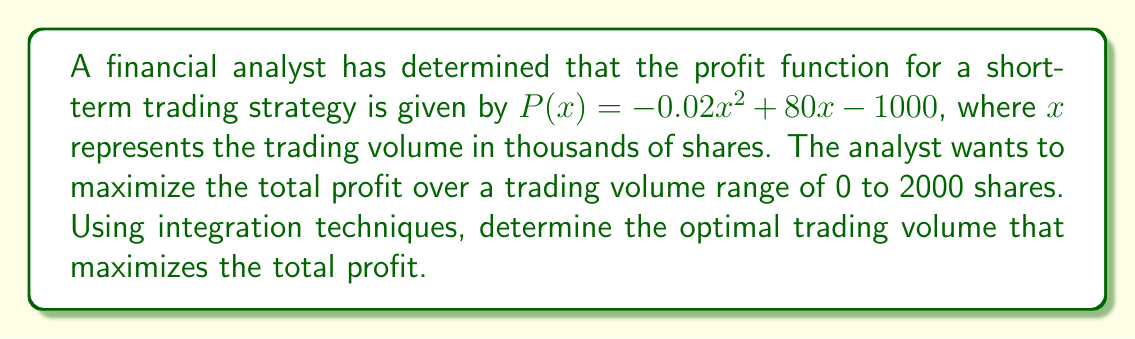Can you solve this math problem? To solve this problem, we'll follow these steps:

1) First, we need to find the total profit function by integrating $P(x)$ over the given range:

   $$\text{Total Profit} = \int_0^2 P(x) dx$$

2) Integrate $P(x)$ with respect to $x$:

   $$\int_0^2 (-0.02x^2 + 80x - 1000) dx$$
   
   $$= [-\frac{0.02}{3}x^3 + 40x^2 - 1000x]_0^2$$

3) Evaluate the integral at the bounds:

   $$= [-\frac{0.02}{3}(2^3) + 40(2^2) - 1000(2)] - [-\frac{0.02}{3}(0^3) + 40(0^2) - 1000(0)]$$
   
   $$= [-0.16 + 160 - 2000] - [0]$$
   
   $$= -1840.16$$

4) To find the optimal trading volume, we need to find the maximum point of the original profit function $P(x)$. We can do this by differentiating $P(x)$ and setting it to zero:

   $$P'(x) = -0.04x + 80$$
   
   Set $P'(x) = 0$:
   
   $$-0.04x + 80 = 0$$
   $$-0.04x = -80$$
   $$x = 2000$$

5) The second derivative $P''(x) = -0.04$ is negative, confirming this is a maximum.

6) Convert the result back to shares (remember $x$ was in thousands of shares):

   Optimal trading volume = 2000 shares
Answer: 2000 shares 